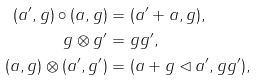Convert formula to latex. <formula><loc_0><loc_0><loc_500><loc_500>( a ^ { \prime } , g ) \circ ( a , g ) & = ( a ^ { \prime } + a , g ) , \\ g \otimes g ^ { \prime } & = g g ^ { \prime } , \\ ( a , g ) \otimes ( a ^ { \prime } , g ^ { \prime } ) & = ( a + g \lhd a ^ { \prime } , g g ^ { \prime } ) ,</formula> 